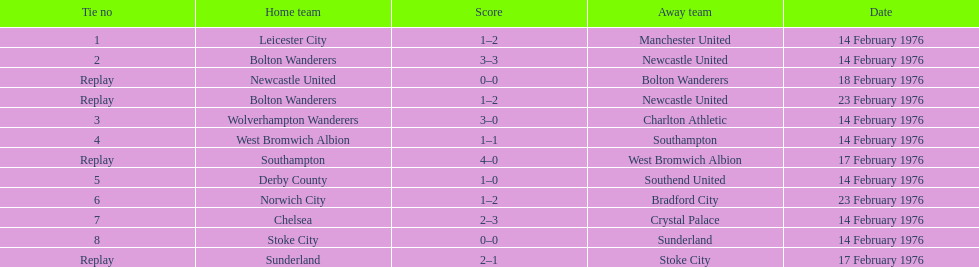Which teams played the same day as leicester city and manchester united? Bolton Wanderers, Newcastle United. 